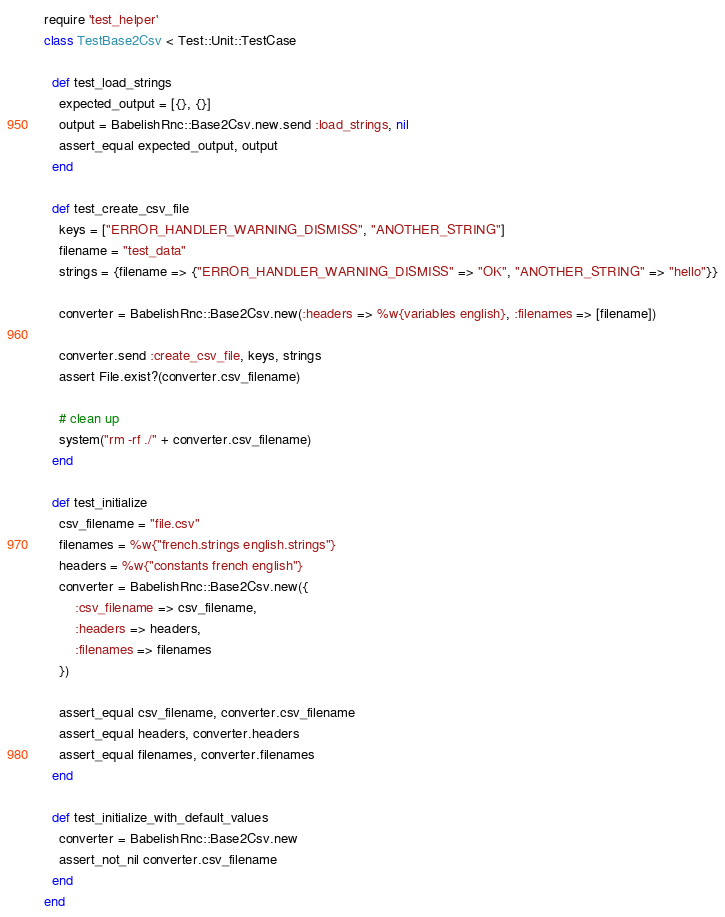Convert code to text. <code><loc_0><loc_0><loc_500><loc_500><_Ruby_>require 'test_helper'
class TestBase2Csv < Test::Unit::TestCase

  def test_load_strings
    expected_output = [{}, {}]
    output = BabelishRnc::Base2Csv.new.send :load_strings, nil
    assert_equal expected_output, output
  end

  def test_create_csv_file
    keys = ["ERROR_HANDLER_WARNING_DISMISS", "ANOTHER_STRING"]
    filename = "test_data"
    strings = {filename => {"ERROR_HANDLER_WARNING_DISMISS" => "OK", "ANOTHER_STRING" => "hello"}}

    converter = BabelishRnc::Base2Csv.new(:headers => %w{variables english}, :filenames => [filename])

    converter.send :create_csv_file, keys, strings
    assert File.exist?(converter.csv_filename)

    # clean up
    system("rm -rf ./" + converter.csv_filename)
  end

  def test_initialize
    csv_filename = "file.csv"
    filenames = %w{"french.strings english.strings"}
    headers = %w{"constants french english"}
    converter = BabelishRnc::Base2Csv.new({
        :csv_filename => csv_filename,
        :headers => headers,
        :filenames => filenames
    })

    assert_equal csv_filename, converter.csv_filename
    assert_equal headers, converter.headers
    assert_equal filenames, converter.filenames
  end

  def test_initialize_with_default_values
    converter = BabelishRnc::Base2Csv.new
    assert_not_nil converter.csv_filename
  end
end
</code> 